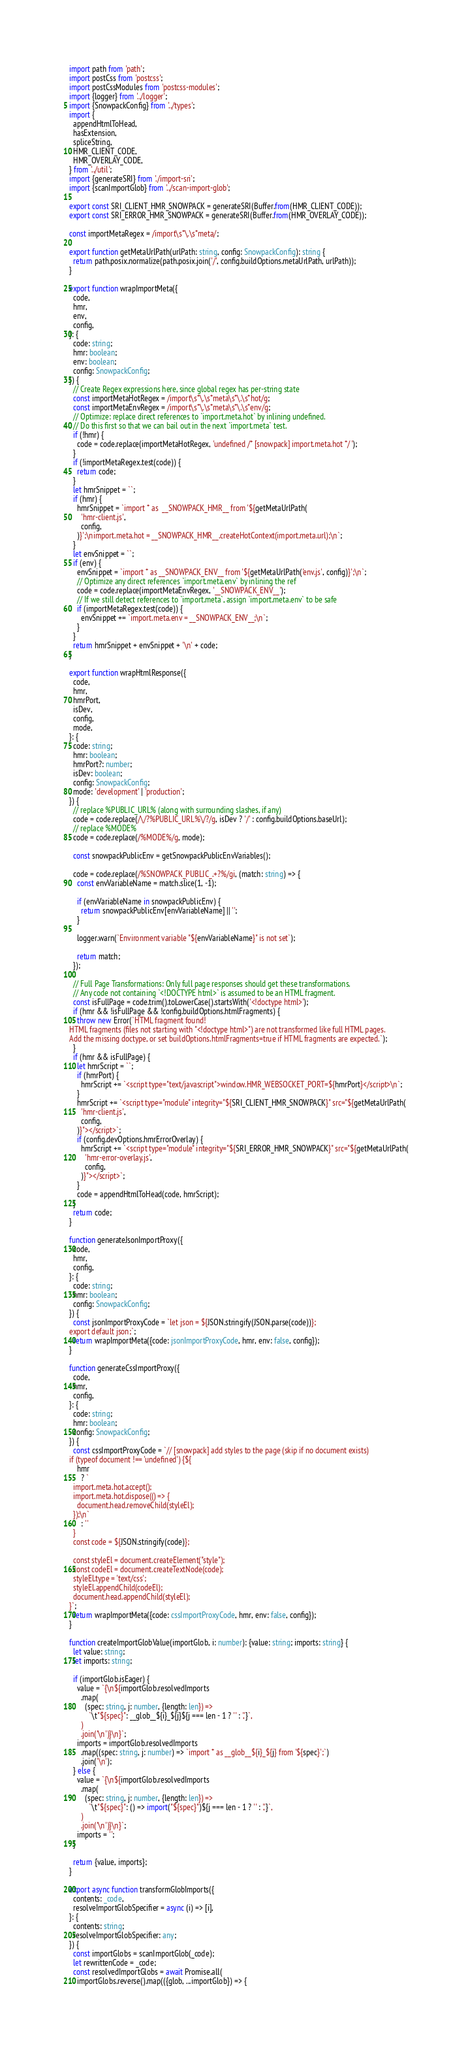Convert code to text. <code><loc_0><loc_0><loc_500><loc_500><_TypeScript_>import path from 'path';
import postCss from 'postcss';
import postCssModules from 'postcss-modules';
import {logger} from '../logger';
import {SnowpackConfig} from '../types';
import {
  appendHtmlToHead,
  hasExtension,
  spliceString,
  HMR_CLIENT_CODE,
  HMR_OVERLAY_CODE,
} from '../util';
import {generateSRI} from './import-sri';
import {scanImportGlob} from '../scan-import-glob';

export const SRI_CLIENT_HMR_SNOWPACK = generateSRI(Buffer.from(HMR_CLIENT_CODE));
export const SRI_ERROR_HMR_SNOWPACK = generateSRI(Buffer.from(HMR_OVERLAY_CODE));

const importMetaRegex = /import\s*\.\s*meta/;

export function getMetaUrlPath(urlPath: string, config: SnowpackConfig): string {
  return path.posix.normalize(path.posix.join('/', config.buildOptions.metaUrlPath, urlPath));
}

export function wrapImportMeta({
  code,
  hmr,
  env,
  config,
}: {
  code: string;
  hmr: boolean;
  env: boolean;
  config: SnowpackConfig;
}) {
  // Create Regex expressions here, since global regex has per-string state
  const importMetaHotRegex = /import\s*\.\s*meta\s*\.\s*hot/g;
  const importMetaEnvRegex = /import\s*\.\s*meta\s*\.\s*env/g;
  // Optimize: replace direct references to `import.meta.hot` by inlining undefined.
  // Do this first so that we can bail out in the next `import.meta` test.
  if (!hmr) {
    code = code.replace(importMetaHotRegex, 'undefined /* [snowpack] import.meta.hot */ ');
  }
  if (!importMetaRegex.test(code)) {
    return code;
  }
  let hmrSnippet = ``;
  if (hmr) {
    hmrSnippet = `import * as  __SNOWPACK_HMR__ from '${getMetaUrlPath(
      'hmr-client.js',
      config,
    )}';\nimport.meta.hot = __SNOWPACK_HMR__.createHotContext(import.meta.url);\n`;
  }
  let envSnippet = ``;
  if (env) {
    envSnippet = `import * as __SNOWPACK_ENV__ from '${getMetaUrlPath('env.js', config)}';\n`;
    // Optimize any direct references `import.meta.env` by inlining the ref
    code = code.replace(importMetaEnvRegex, '__SNOWPACK_ENV__');
    // If we still detect references to `import.meta`, assign `import.meta.env` to be safe
    if (importMetaRegex.test(code)) {
      envSnippet += `import.meta.env = __SNOWPACK_ENV__;\n`;
    }
  }
  return hmrSnippet + envSnippet + '\n' + code;
}

export function wrapHtmlResponse({
  code,
  hmr,
  hmrPort,
  isDev,
  config,
  mode,
}: {
  code: string;
  hmr: boolean;
  hmrPort?: number;
  isDev: boolean;
  config: SnowpackConfig;
  mode: 'development' | 'production';
}) {
  // replace %PUBLIC_URL% (along with surrounding slashes, if any)
  code = code.replace(/\/?%PUBLIC_URL%\/?/g, isDev ? '/' : config.buildOptions.baseUrl);
  // replace %MODE%
  code = code.replace(/%MODE%/g, mode);

  const snowpackPublicEnv = getSnowpackPublicEnvVariables();

  code = code.replace(/%SNOWPACK_PUBLIC_.+?%/gi, (match: string) => {
    const envVariableName = match.slice(1, -1);

    if (envVariableName in snowpackPublicEnv) {
      return snowpackPublicEnv[envVariableName] || '';
    }

    logger.warn(`Environment variable "${envVariableName}" is not set`);

    return match;
  });

  // Full Page Transformations: Only full page responses should get these transformations.
  // Any code not containing `<!DOCTYPE html>` is assumed to be an HTML fragment.
  const isFullPage = code.trim().toLowerCase().startsWith('<!doctype html>');
  if (hmr && !isFullPage && !config.buildOptions.htmlFragments) {
    throw new Error(`HTML fragment found!
HTML fragments (files not starting with "<!doctype html>") are not transformed like full HTML pages.
Add the missing doctype, or set buildOptions.htmlFragments=true if HTML fragments are expected.`);
  }
  if (hmr && isFullPage) {
    let hmrScript = ``;
    if (hmrPort) {
      hmrScript += `<script type="text/javascript">window.HMR_WEBSOCKET_PORT=${hmrPort}</script>\n`;
    }
    hmrScript += `<script type="module" integrity="${SRI_CLIENT_HMR_SNOWPACK}" src="${getMetaUrlPath(
      'hmr-client.js',
      config,
    )}"></script>`;
    if (config.devOptions.hmrErrorOverlay) {
      hmrScript += `<script type="module" integrity="${SRI_ERROR_HMR_SNOWPACK}" src="${getMetaUrlPath(
        'hmr-error-overlay.js',
        config,
      )}"></script>`;
    }
    code = appendHtmlToHead(code, hmrScript);
  }
  return code;
}

function generateJsonImportProxy({
  code,
  hmr,
  config,
}: {
  code: string;
  hmr: boolean;
  config: SnowpackConfig;
}) {
  const jsonImportProxyCode = `let json = ${JSON.stringify(JSON.parse(code))};
export default json;`;
  return wrapImportMeta({code: jsonImportProxyCode, hmr, env: false, config});
}

function generateCssImportProxy({
  code,
  hmr,
  config,
}: {
  code: string;
  hmr: boolean;
  config: SnowpackConfig;
}) {
  const cssImportProxyCode = `// [snowpack] add styles to the page (skip if no document exists)
if (typeof document !== 'undefined') {${
    hmr
      ? `
  import.meta.hot.accept();
  import.meta.hot.dispose(() => {
    document.head.removeChild(styleEl);
  });\n`
      : ''
  }
  const code = ${JSON.stringify(code)};

  const styleEl = document.createElement("style");
  const codeEl = document.createTextNode(code);
  styleEl.type = 'text/css';
  styleEl.appendChild(codeEl);
  document.head.appendChild(styleEl);
}`;
  return wrapImportMeta({code: cssImportProxyCode, hmr, env: false, config});
}

function createImportGlobValue(importGlob, i: number): {value: string; imports: string} {
  let value: string;
  let imports: string;

  if (importGlob.isEager) {
    value = `{\n${importGlob.resolvedImports
      .map(
        (spec: string, j: number, {length: len}) =>
          `\t"${spec}": __glob__${i}_${j}${j === len - 1 ? '' : ','}`,
      )
      .join('\n')}\n}`;
    imports = importGlob.resolvedImports
      .map((spec: string, j: number) => `import * as __glob__${i}_${j} from '${spec}';`)
      .join('\n');
  } else {
    value = `{\n${importGlob.resolvedImports
      .map(
        (spec: string, j: number, {length: len}) =>
          `\t"${spec}": () => import("${spec}")${j === len - 1 ? '' : ','}`,
      )
      .join('\n')}\n}`;
    imports = '';
  }

  return {value, imports};
}

export async function transformGlobImports({
  contents: _code,
  resolveImportGlobSpecifier = async (i) => [i],
}: {
  contents: string;
  resolveImportGlobSpecifier: any;
}) {
  const importGlobs = scanImportGlob(_code);
  let rewrittenCode = _code;
  const resolvedImportGlobs = await Promise.all(
    importGlobs.reverse().map(({glob, ...importGlob}) => {</code> 